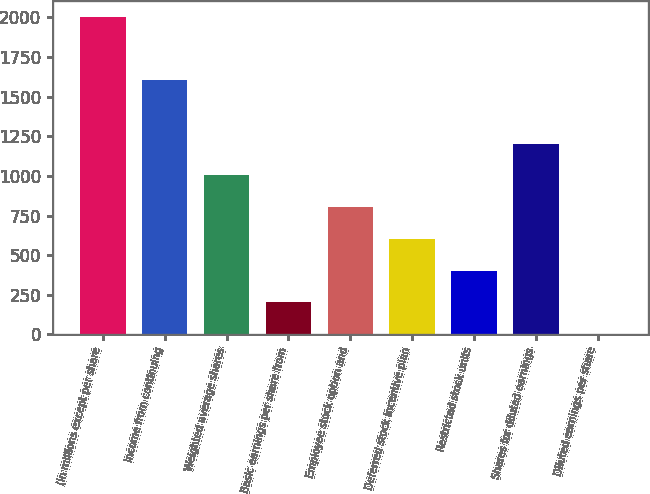Convert chart. <chart><loc_0><loc_0><loc_500><loc_500><bar_chart><fcel>(in millions except per share<fcel>Income from continuing<fcel>Weighted average shares<fcel>Basic earnings per share from<fcel>Employee stock option and<fcel>Deferred stock incentive plan<fcel>Restricted stock units<fcel>Shares for diluted earnings<fcel>Diluted earnings per share<nl><fcel>2006<fcel>1605.1<fcel>1003.81<fcel>202.09<fcel>803.38<fcel>602.95<fcel>402.52<fcel>1204.24<fcel>1.66<nl></chart> 